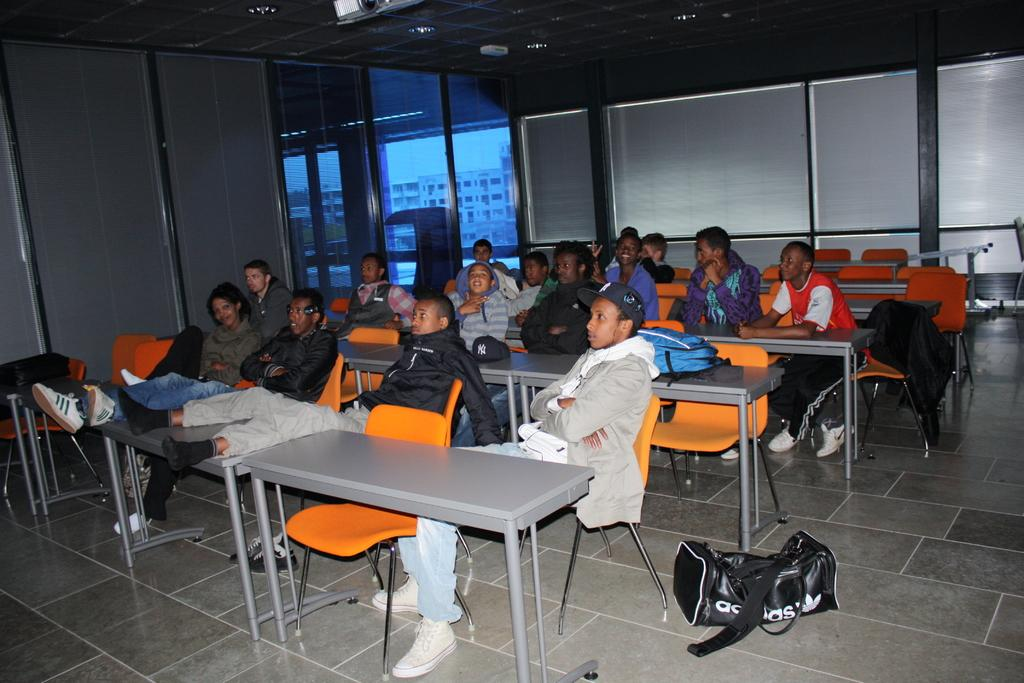What are the people in the image doing? The people in the image are sitting on chairs. Where are the people located in relation to the desk? The people are in front of a desk. What is the facial expression of the people in the image? The people are staring. What type of setting is suggested by the presence of chairs, a desk, and windows? The setting appears to be a classroom. What is visible on the back wall of the room? There are windows on the back wall of the room. Are there any window treatments present in the image? Yes, there are curtains associated with the windows. What type of rail can be seen in the image? There is no rail present in the image. What religious symbols are visible in the image? There are no religious symbols visible in the image. 